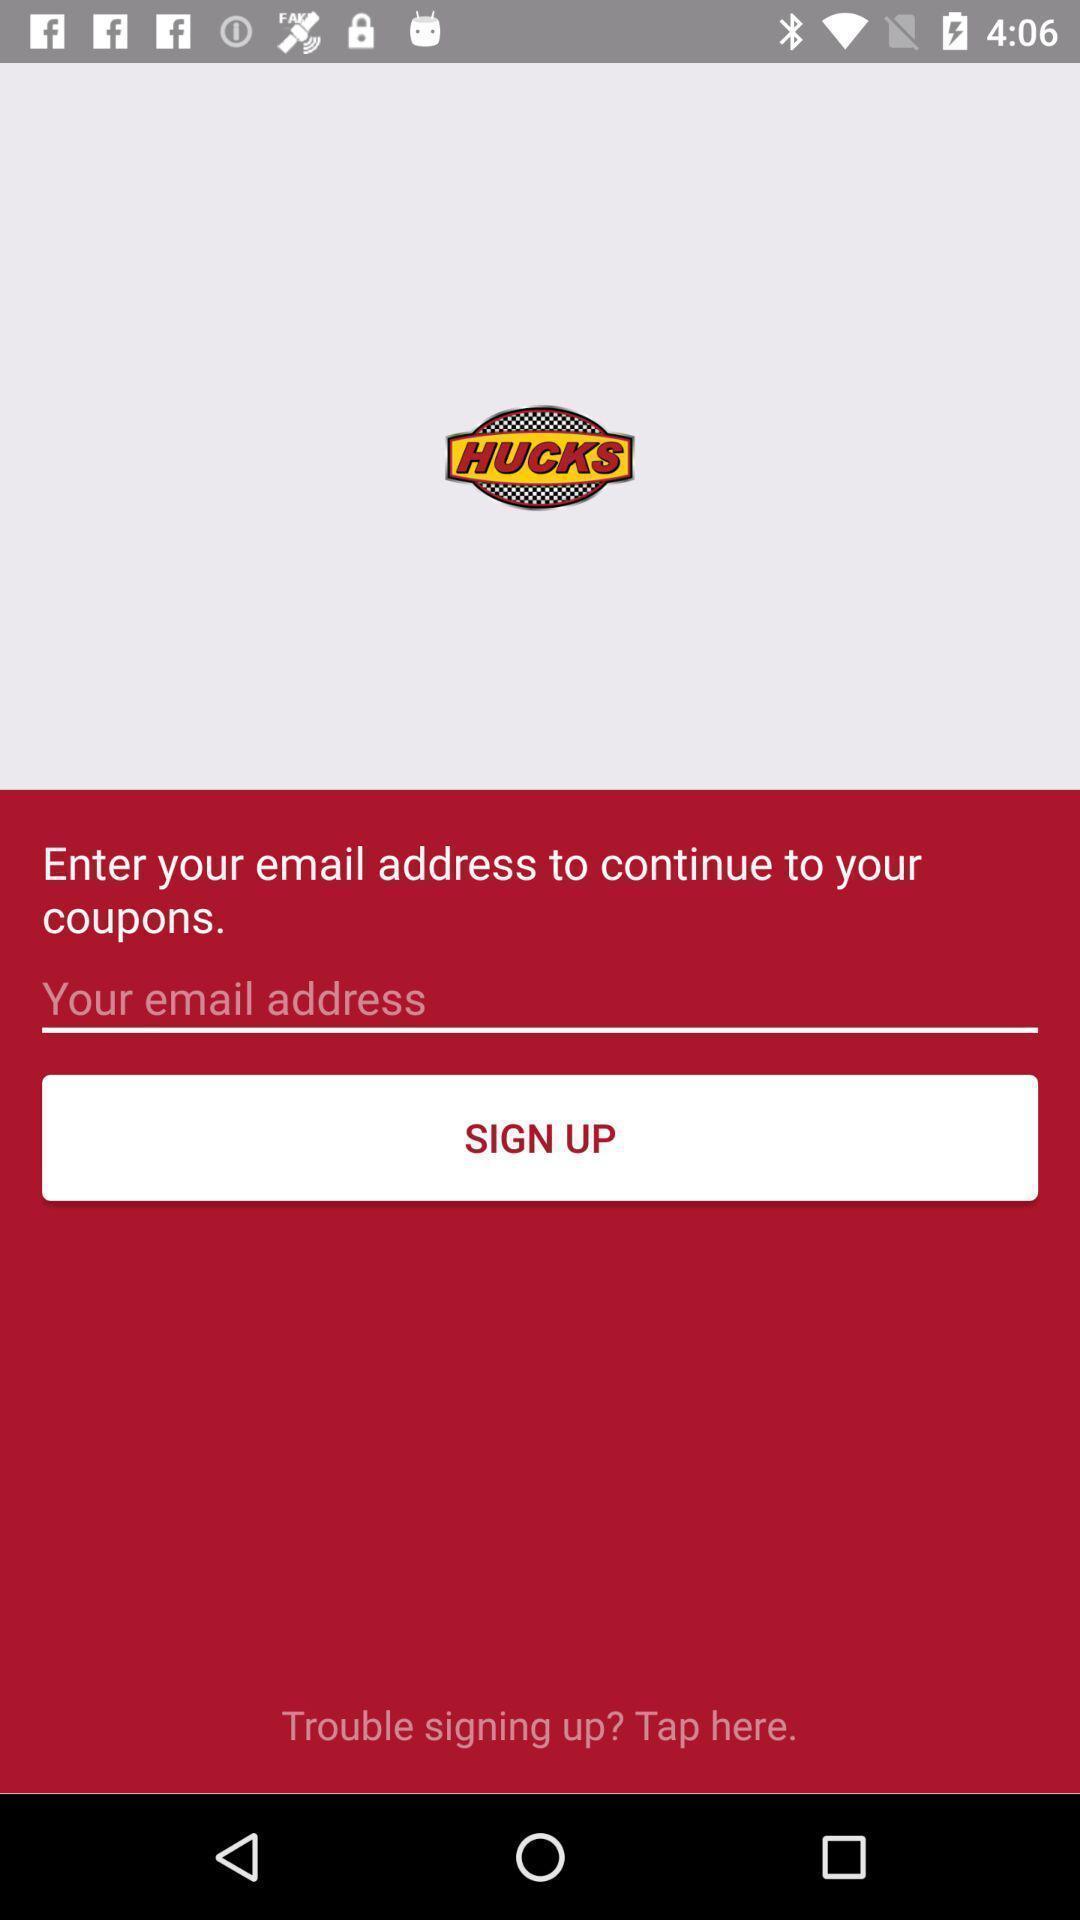Describe the content in this image. Sign up page. 